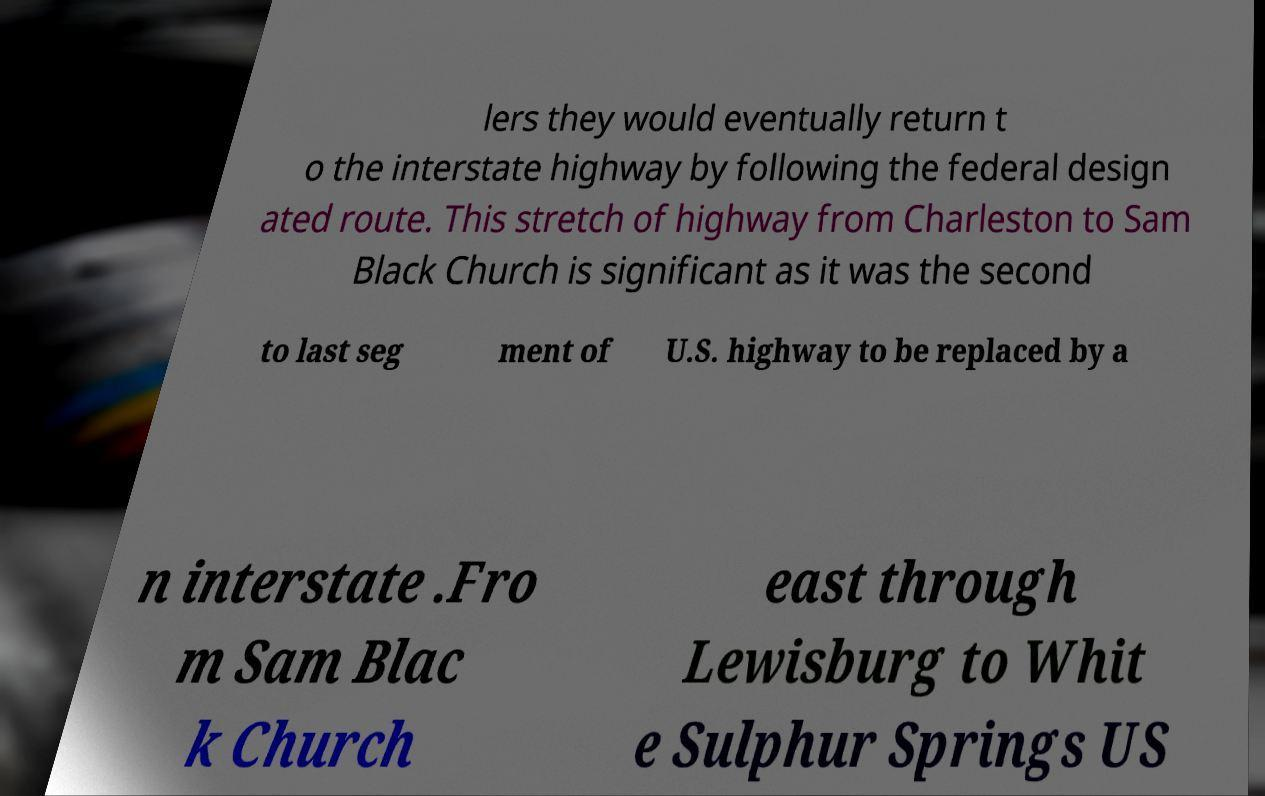For documentation purposes, I need the text within this image transcribed. Could you provide that? lers they would eventually return t o the interstate highway by following the federal design ated route. This stretch of highway from Charleston to Sam Black Church is significant as it was the second to last seg ment of U.S. highway to be replaced by a n interstate .Fro m Sam Blac k Church east through Lewisburg to Whit e Sulphur Springs US 